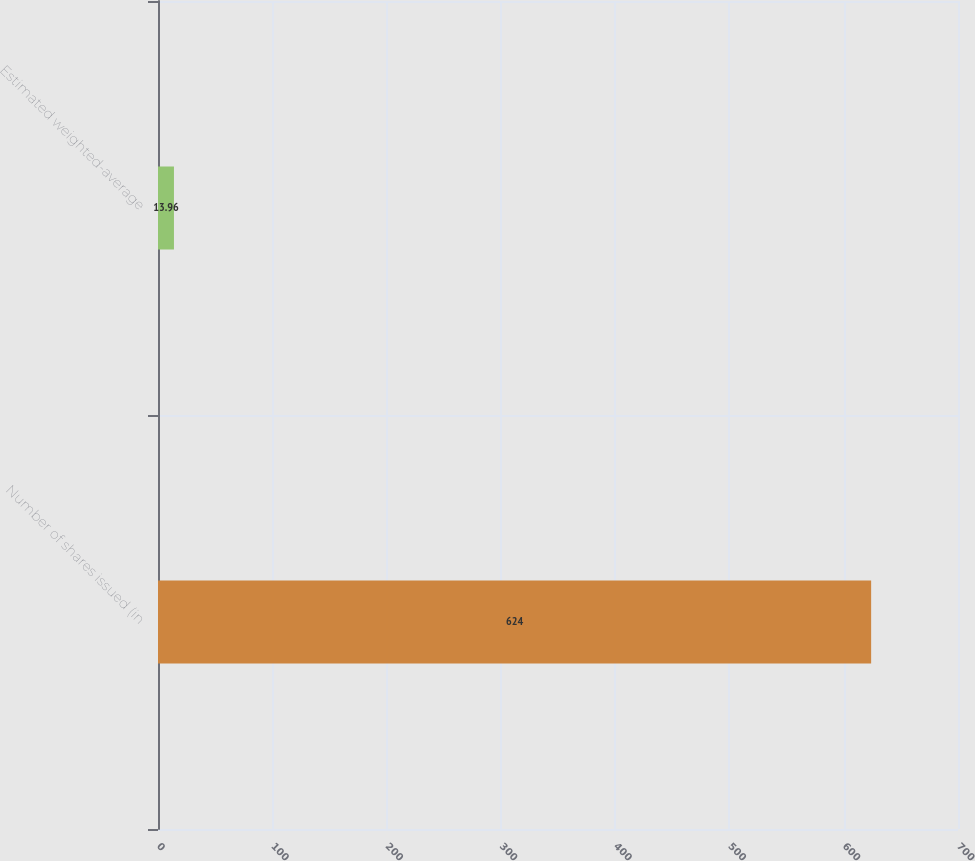Convert chart to OTSL. <chart><loc_0><loc_0><loc_500><loc_500><bar_chart><fcel>Number of shares issued (in<fcel>Estimated weighted-average<nl><fcel>624<fcel>13.96<nl></chart> 